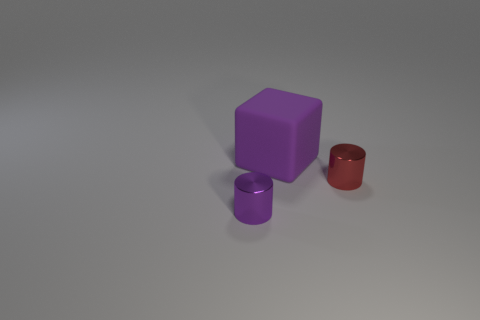Is there any other thing that is the same size as the rubber thing?
Make the answer very short. No. There is a thing that is both behind the small purple thing and left of the tiny red cylinder; how big is it?
Provide a succinct answer. Large. What is the shape of the small red shiny object?
Provide a succinct answer. Cylinder. How many other big rubber things are the same shape as the large purple rubber thing?
Offer a terse response. 0. Is the number of small red shiny objects on the right side of the small red thing less than the number of cylinders that are on the right side of the purple rubber object?
Offer a terse response. Yes. There is a object right of the purple cube; what number of tiny shiny objects are behind it?
Your response must be concise. 0. Are any red cylinders visible?
Your answer should be very brief. Yes. Is there a small purple block made of the same material as the large cube?
Offer a very short reply. No. Are there more small purple metal things in front of the tiny red shiny object than small metallic objects behind the big matte block?
Ensure brevity in your answer.  Yes. Does the purple cylinder have the same size as the red thing?
Offer a terse response. Yes. 